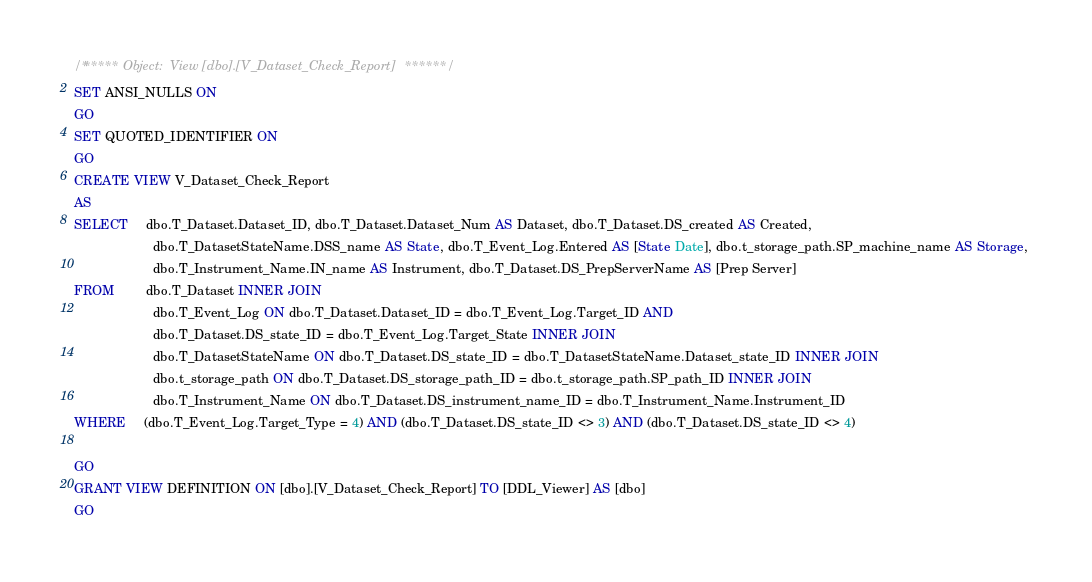Convert code to text. <code><loc_0><loc_0><loc_500><loc_500><_SQL_>/****** Object:  View [dbo].[V_Dataset_Check_Report] ******/
SET ANSI_NULLS ON
GO
SET QUOTED_IDENTIFIER ON
GO
CREATE VIEW V_Dataset_Check_Report
AS
SELECT     dbo.T_Dataset.Dataset_ID, dbo.T_Dataset.Dataset_Num AS Dataset, dbo.T_Dataset.DS_created AS Created, 
                      dbo.T_DatasetStateName.DSS_name AS State, dbo.T_Event_Log.Entered AS [State Date], dbo.t_storage_path.SP_machine_name AS Storage, 
                      dbo.T_Instrument_Name.IN_name AS Instrument, dbo.T_Dataset.DS_PrepServerName AS [Prep Server]
FROM         dbo.T_Dataset INNER JOIN
                      dbo.T_Event_Log ON dbo.T_Dataset.Dataset_ID = dbo.T_Event_Log.Target_ID AND 
                      dbo.T_Dataset.DS_state_ID = dbo.T_Event_Log.Target_State INNER JOIN
                      dbo.T_DatasetStateName ON dbo.T_Dataset.DS_state_ID = dbo.T_DatasetStateName.Dataset_state_ID INNER JOIN
                      dbo.t_storage_path ON dbo.T_Dataset.DS_storage_path_ID = dbo.t_storage_path.SP_path_ID INNER JOIN
                      dbo.T_Instrument_Name ON dbo.T_Dataset.DS_instrument_name_ID = dbo.T_Instrument_Name.Instrument_ID
WHERE     (dbo.T_Event_Log.Target_Type = 4) AND (dbo.T_Dataset.DS_state_ID <> 3) AND (dbo.T_Dataset.DS_state_ID <> 4)

GO
GRANT VIEW DEFINITION ON [dbo].[V_Dataset_Check_Report] TO [DDL_Viewer] AS [dbo]
GO
</code> 